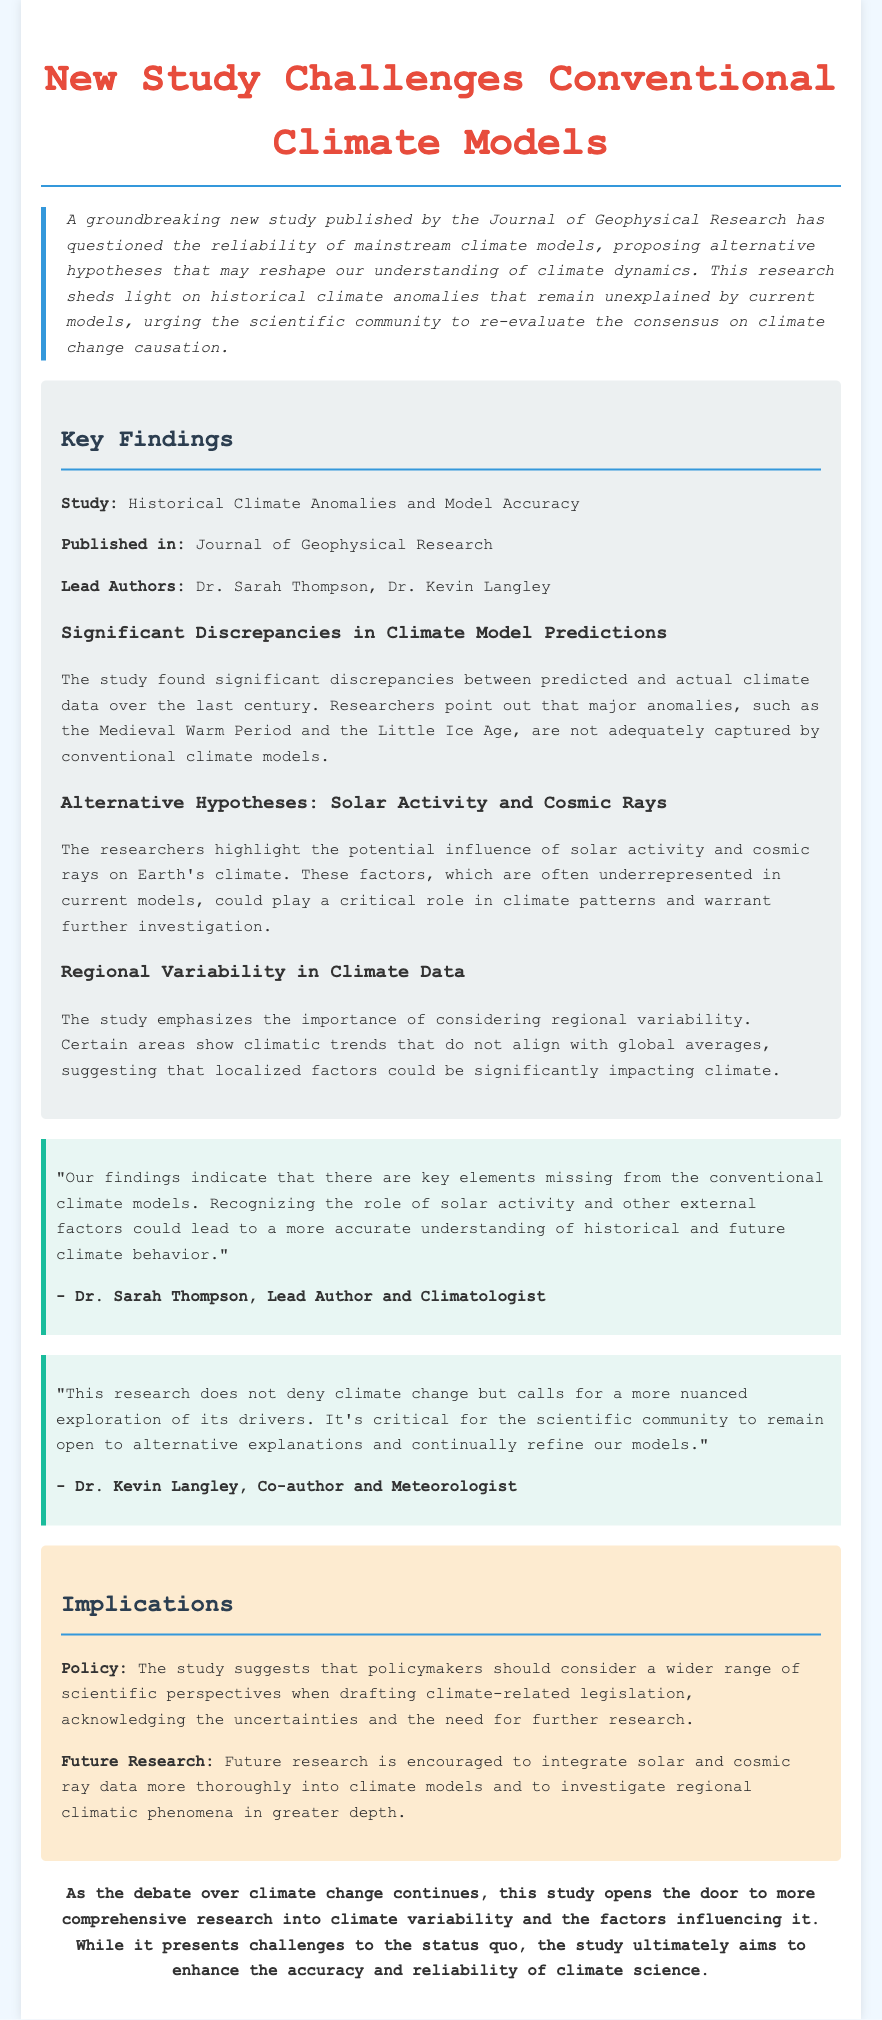What is the title of the study? The title of the study is included in the document, specifically in the headline.
Answer: New Study Challenges Conventional Climate Models Who are the lead authors of the study? The lead authors are mentioned in the key findings section of the document.
Answer: Dr. Sarah Thompson, Dr. Kevin Langley What publication featured the study? The study's publication is specified in the key findings section.
Answer: Journal of Geophysical Research What major historical anomalies does the study mention? The text points out specific historical anomalies related to climate in the key findings section.
Answer: Medieval Warm Period and the Little Ice Age What do the researchers propose should be integrated into climate models? The implications section outlines what the researchers suggest for future research.
Answer: Solar and cosmic ray data What is indicated as a necessary consideration for policymakers? The implications section contains recommendations for policymakers related to legislation.
Answer: A wider range of scientific perspectives What is the primary message from Dr. Sarah Thompson? Dr. Sarah Thompson's perspective is given in a quote in the document that expresses a key finding of the study.
Answer: Key elements missing from conventional climate models How does the study relate to climate change skepticism? The implications in the document suggest a critical view of mainstream models and encourages alternative perspectives.
Answer: A more nuanced exploration of its drivers What does the study call for regarding future research? The implications section indicates what the study recommends for ongoing scientific inquiry.
Answer: Further research 